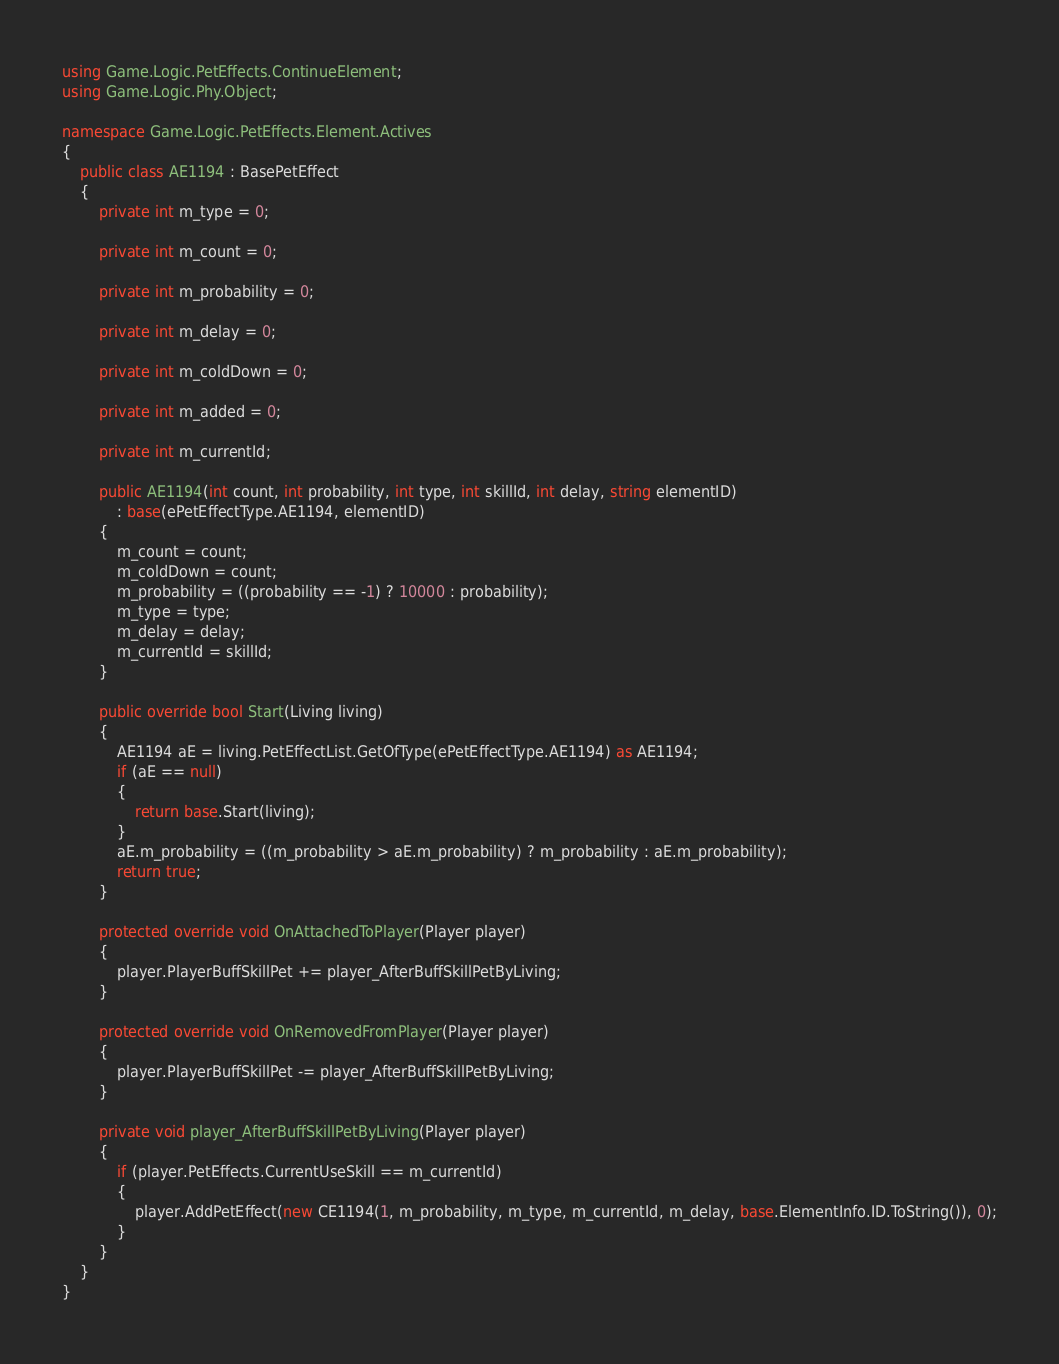<code> <loc_0><loc_0><loc_500><loc_500><_C#_>using Game.Logic.PetEffects.ContinueElement;
using Game.Logic.Phy.Object;

namespace Game.Logic.PetEffects.Element.Actives
{
	public class AE1194 : BasePetEffect
	{
		private int m_type = 0;

		private int m_count = 0;

		private int m_probability = 0;

		private int m_delay = 0;

		private int m_coldDown = 0;

		private int m_added = 0;

		private int m_currentId;

		public AE1194(int count, int probability, int type, int skillId, int delay, string elementID)
			: base(ePetEffectType.AE1194, elementID)
		{
			m_count = count;
			m_coldDown = count;
			m_probability = ((probability == -1) ? 10000 : probability);
			m_type = type;
			m_delay = delay;
			m_currentId = skillId;
		}

		public override bool Start(Living living)
		{
			AE1194 aE = living.PetEffectList.GetOfType(ePetEffectType.AE1194) as AE1194;
			if (aE == null)
			{
				return base.Start(living);
			}
			aE.m_probability = ((m_probability > aE.m_probability) ? m_probability : aE.m_probability);
			return true;
		}

		protected override void OnAttachedToPlayer(Player player)
		{
			player.PlayerBuffSkillPet += player_AfterBuffSkillPetByLiving;
		}

		protected override void OnRemovedFromPlayer(Player player)
		{
			player.PlayerBuffSkillPet -= player_AfterBuffSkillPetByLiving;
		}

		private void player_AfterBuffSkillPetByLiving(Player player)
		{
			if (player.PetEffects.CurrentUseSkill == m_currentId)
			{
				player.AddPetEffect(new CE1194(1, m_probability, m_type, m_currentId, m_delay, base.ElementInfo.ID.ToString()), 0);
			}
		}
	}
}
</code> 